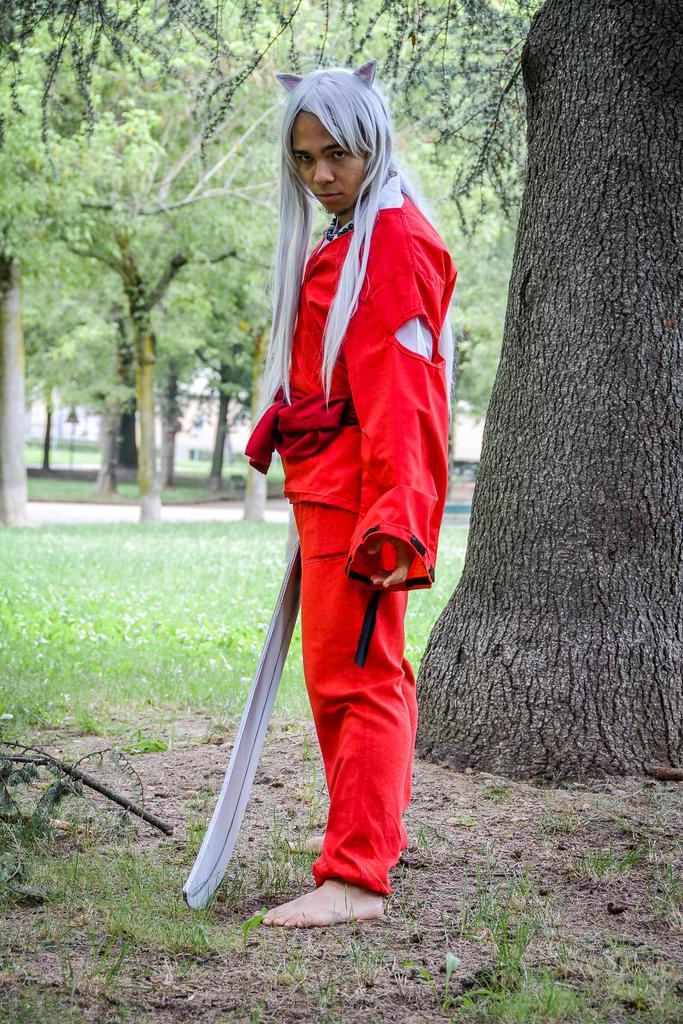Please provide a concise description of this image. In this image, at the middle there is a person standing, the person is wearing red color clothes, there is a black color tree trunk at the right side, at the background there is green color grass on the ground and there are some green color trees. 